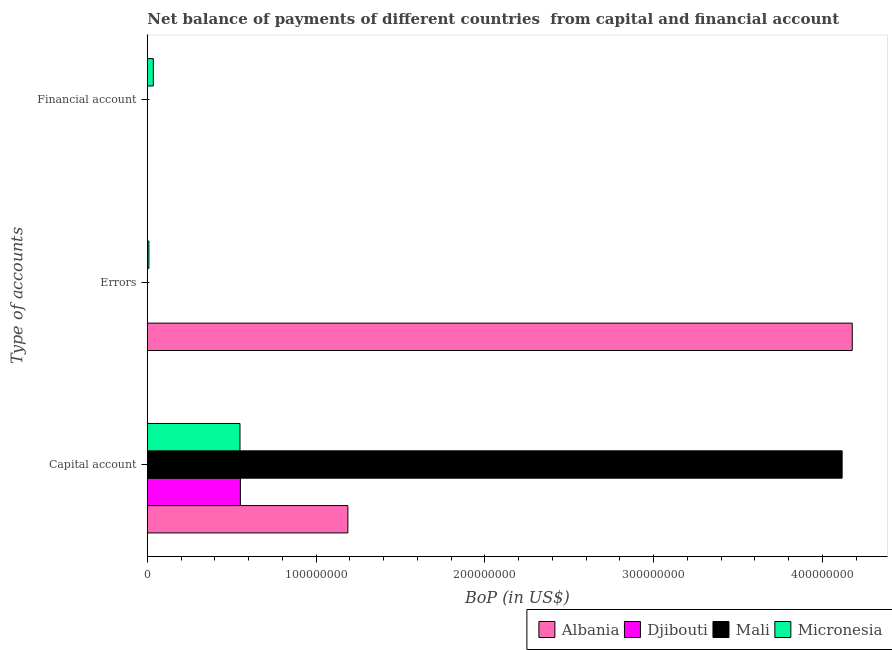What is the label of the 1st group of bars from the top?
Keep it short and to the point. Financial account. What is the amount of financial account in Micronesia?
Your answer should be compact. 3.54e+06. Across all countries, what is the maximum amount of errors?
Your response must be concise. 4.18e+08. Across all countries, what is the minimum amount of errors?
Provide a succinct answer. 0. In which country was the amount of errors maximum?
Offer a terse response. Albania. What is the total amount of financial account in the graph?
Keep it short and to the point. 3.54e+06. What is the difference between the amount of net capital account in Mali and that in Micronesia?
Your response must be concise. 3.57e+08. What is the difference between the amount of financial account in Djibouti and the amount of errors in Micronesia?
Your answer should be very brief. -9.18e+05. What is the average amount of errors per country?
Your answer should be very brief. 1.05e+08. What is the difference between the amount of financial account and amount of errors in Micronesia?
Provide a succinct answer. 2.62e+06. In how many countries, is the amount of errors greater than 100000000 US$?
Make the answer very short. 1. What is the ratio of the amount of errors in Albania to that in Micronesia?
Provide a succinct answer. 455.06. What is the difference between the highest and the lowest amount of net capital account?
Your answer should be compact. 3.57e+08. In how many countries, is the amount of financial account greater than the average amount of financial account taken over all countries?
Offer a terse response. 1. Is the sum of the amount of net capital account in Micronesia and Djibouti greater than the maximum amount of errors across all countries?
Your answer should be compact. No. Is it the case that in every country, the sum of the amount of net capital account and amount of errors is greater than the amount of financial account?
Provide a short and direct response. Yes. How many bars are there?
Provide a short and direct response. 7. Are the values on the major ticks of X-axis written in scientific E-notation?
Your response must be concise. No. Does the graph contain any zero values?
Your answer should be very brief. Yes. Does the graph contain grids?
Offer a very short reply. No. What is the title of the graph?
Provide a short and direct response. Net balance of payments of different countries  from capital and financial account. What is the label or title of the X-axis?
Your response must be concise. BoP (in US$). What is the label or title of the Y-axis?
Your response must be concise. Type of accounts. What is the BoP (in US$) in Albania in Capital account?
Your answer should be compact. 1.19e+08. What is the BoP (in US$) in Djibouti in Capital account?
Offer a very short reply. 5.51e+07. What is the BoP (in US$) in Mali in Capital account?
Offer a very short reply. 4.12e+08. What is the BoP (in US$) of Micronesia in Capital account?
Give a very brief answer. 5.49e+07. What is the BoP (in US$) in Albania in Errors?
Offer a very short reply. 4.18e+08. What is the BoP (in US$) of Mali in Errors?
Your answer should be compact. 0. What is the BoP (in US$) of Micronesia in Errors?
Provide a succinct answer. 9.18e+05. What is the BoP (in US$) in Albania in Financial account?
Ensure brevity in your answer.  0. What is the BoP (in US$) of Djibouti in Financial account?
Your response must be concise. 0. What is the BoP (in US$) in Mali in Financial account?
Provide a succinct answer. 0. What is the BoP (in US$) of Micronesia in Financial account?
Your answer should be compact. 3.54e+06. Across all Type of accounts, what is the maximum BoP (in US$) in Albania?
Offer a very short reply. 4.18e+08. Across all Type of accounts, what is the maximum BoP (in US$) of Djibouti?
Make the answer very short. 5.51e+07. Across all Type of accounts, what is the maximum BoP (in US$) in Mali?
Keep it short and to the point. 4.12e+08. Across all Type of accounts, what is the maximum BoP (in US$) of Micronesia?
Make the answer very short. 5.49e+07. Across all Type of accounts, what is the minimum BoP (in US$) of Albania?
Keep it short and to the point. 0. Across all Type of accounts, what is the minimum BoP (in US$) of Mali?
Make the answer very short. 0. Across all Type of accounts, what is the minimum BoP (in US$) in Micronesia?
Your response must be concise. 9.18e+05. What is the total BoP (in US$) in Albania in the graph?
Your answer should be compact. 5.36e+08. What is the total BoP (in US$) in Djibouti in the graph?
Your answer should be very brief. 5.51e+07. What is the total BoP (in US$) in Mali in the graph?
Keep it short and to the point. 4.12e+08. What is the total BoP (in US$) in Micronesia in the graph?
Offer a very short reply. 5.93e+07. What is the difference between the BoP (in US$) in Albania in Capital account and that in Errors?
Provide a succinct answer. -2.99e+08. What is the difference between the BoP (in US$) of Micronesia in Capital account and that in Errors?
Offer a very short reply. 5.40e+07. What is the difference between the BoP (in US$) of Micronesia in Capital account and that in Financial account?
Make the answer very short. 5.13e+07. What is the difference between the BoP (in US$) in Micronesia in Errors and that in Financial account?
Your answer should be very brief. -2.62e+06. What is the difference between the BoP (in US$) of Albania in Capital account and the BoP (in US$) of Micronesia in Errors?
Offer a terse response. 1.18e+08. What is the difference between the BoP (in US$) in Djibouti in Capital account and the BoP (in US$) in Micronesia in Errors?
Keep it short and to the point. 5.42e+07. What is the difference between the BoP (in US$) of Mali in Capital account and the BoP (in US$) of Micronesia in Errors?
Your answer should be compact. 4.11e+08. What is the difference between the BoP (in US$) of Albania in Capital account and the BoP (in US$) of Micronesia in Financial account?
Ensure brevity in your answer.  1.15e+08. What is the difference between the BoP (in US$) of Djibouti in Capital account and the BoP (in US$) of Micronesia in Financial account?
Give a very brief answer. 5.16e+07. What is the difference between the BoP (in US$) of Mali in Capital account and the BoP (in US$) of Micronesia in Financial account?
Make the answer very short. 4.08e+08. What is the difference between the BoP (in US$) in Albania in Errors and the BoP (in US$) in Micronesia in Financial account?
Give a very brief answer. 4.14e+08. What is the average BoP (in US$) of Albania per Type of accounts?
Provide a short and direct response. 1.79e+08. What is the average BoP (in US$) of Djibouti per Type of accounts?
Your answer should be compact. 1.84e+07. What is the average BoP (in US$) of Mali per Type of accounts?
Your answer should be very brief. 1.37e+08. What is the average BoP (in US$) of Micronesia per Type of accounts?
Your response must be concise. 1.98e+07. What is the difference between the BoP (in US$) in Albania and BoP (in US$) in Djibouti in Capital account?
Provide a short and direct response. 6.37e+07. What is the difference between the BoP (in US$) in Albania and BoP (in US$) in Mali in Capital account?
Your response must be concise. -2.93e+08. What is the difference between the BoP (in US$) of Albania and BoP (in US$) of Micronesia in Capital account?
Ensure brevity in your answer.  6.39e+07. What is the difference between the BoP (in US$) in Djibouti and BoP (in US$) in Mali in Capital account?
Provide a succinct answer. -3.57e+08. What is the difference between the BoP (in US$) of Djibouti and BoP (in US$) of Micronesia in Capital account?
Offer a terse response. 2.46e+05. What is the difference between the BoP (in US$) of Mali and BoP (in US$) of Micronesia in Capital account?
Your answer should be very brief. 3.57e+08. What is the difference between the BoP (in US$) in Albania and BoP (in US$) in Micronesia in Errors?
Keep it short and to the point. 4.17e+08. What is the ratio of the BoP (in US$) in Albania in Capital account to that in Errors?
Offer a terse response. 0.28. What is the ratio of the BoP (in US$) in Micronesia in Capital account to that in Errors?
Give a very brief answer. 59.8. What is the ratio of the BoP (in US$) of Micronesia in Capital account to that in Financial account?
Provide a succinct answer. 15.51. What is the ratio of the BoP (in US$) of Micronesia in Errors to that in Financial account?
Make the answer very short. 0.26. What is the difference between the highest and the second highest BoP (in US$) of Micronesia?
Ensure brevity in your answer.  5.13e+07. What is the difference between the highest and the lowest BoP (in US$) in Albania?
Give a very brief answer. 4.18e+08. What is the difference between the highest and the lowest BoP (in US$) of Djibouti?
Ensure brevity in your answer.  5.51e+07. What is the difference between the highest and the lowest BoP (in US$) in Mali?
Your answer should be very brief. 4.12e+08. What is the difference between the highest and the lowest BoP (in US$) of Micronesia?
Provide a short and direct response. 5.40e+07. 